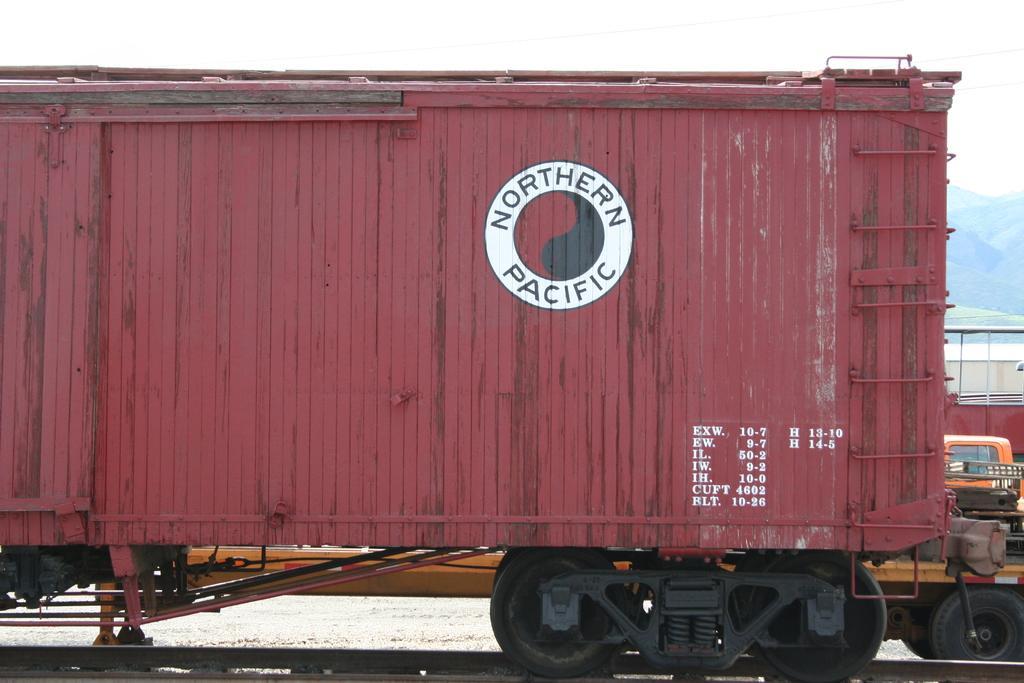How would you summarize this image in a sentence or two? In this image I can see a part of the train which is red, black and white in color on the railway track. In the background I can see a vehicle which is yellow and black in color, few mountains and the sky. 